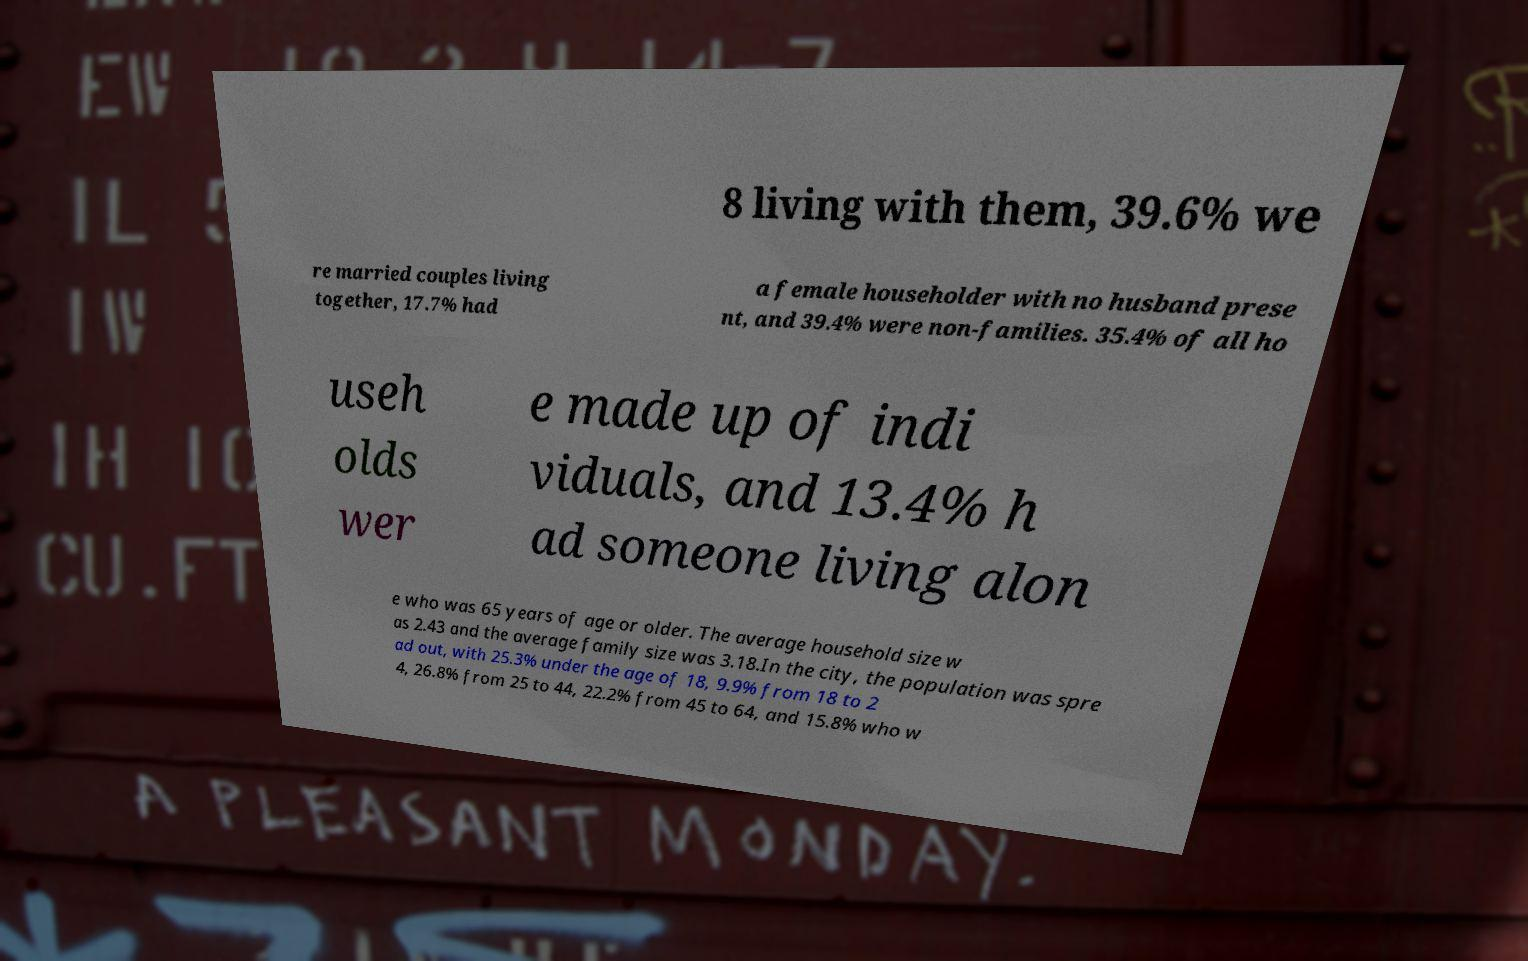For documentation purposes, I need the text within this image transcribed. Could you provide that? 8 living with them, 39.6% we re married couples living together, 17.7% had a female householder with no husband prese nt, and 39.4% were non-families. 35.4% of all ho useh olds wer e made up of indi viduals, and 13.4% h ad someone living alon e who was 65 years of age or older. The average household size w as 2.43 and the average family size was 3.18.In the city, the population was spre ad out, with 25.3% under the age of 18, 9.9% from 18 to 2 4, 26.8% from 25 to 44, 22.2% from 45 to 64, and 15.8% who w 